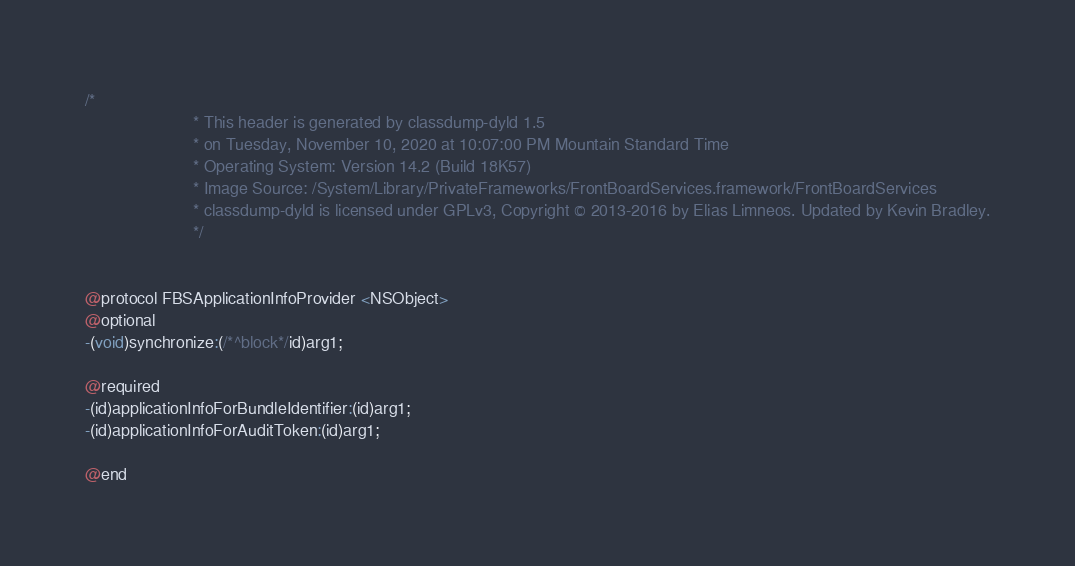Convert code to text. <code><loc_0><loc_0><loc_500><loc_500><_C_>/*
                       * This header is generated by classdump-dyld 1.5
                       * on Tuesday, November 10, 2020 at 10:07:00 PM Mountain Standard Time
                       * Operating System: Version 14.2 (Build 18K57)
                       * Image Source: /System/Library/PrivateFrameworks/FrontBoardServices.framework/FrontBoardServices
                       * classdump-dyld is licensed under GPLv3, Copyright © 2013-2016 by Elias Limneos. Updated by Kevin Bradley.
                       */


@protocol FBSApplicationInfoProvider <NSObject>
@optional
-(void)synchronize:(/*^block*/id)arg1;

@required
-(id)applicationInfoForBundleIdentifier:(id)arg1;
-(id)applicationInfoForAuditToken:(id)arg1;

@end

</code> 